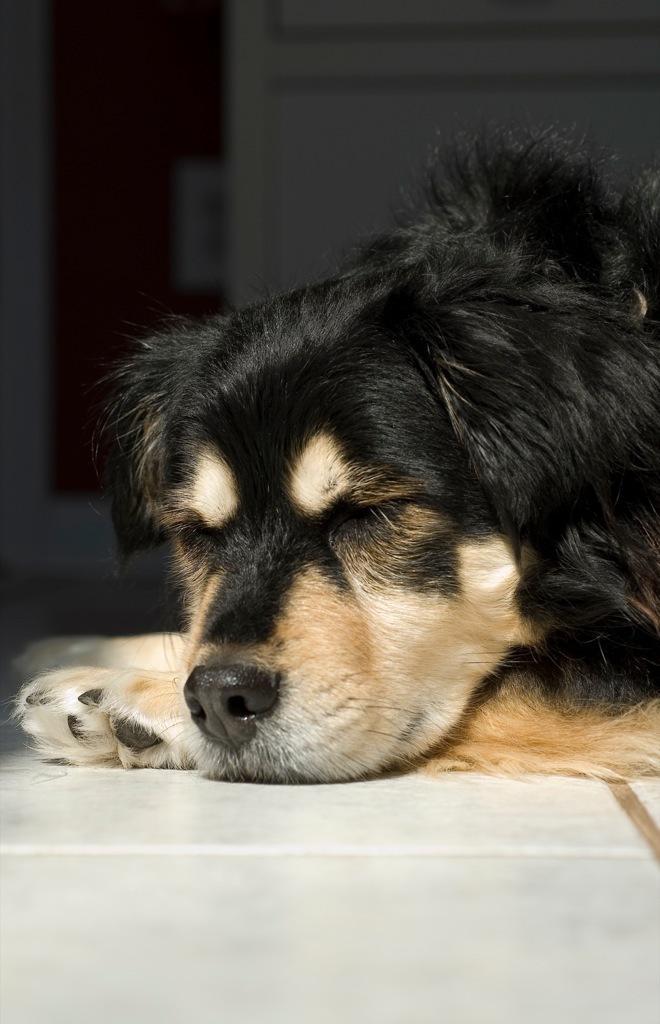Can you describe this image briefly? In this picture there is a dog lying on the ground. It is in black and brown in color. On the top, there is a wall with a door. 